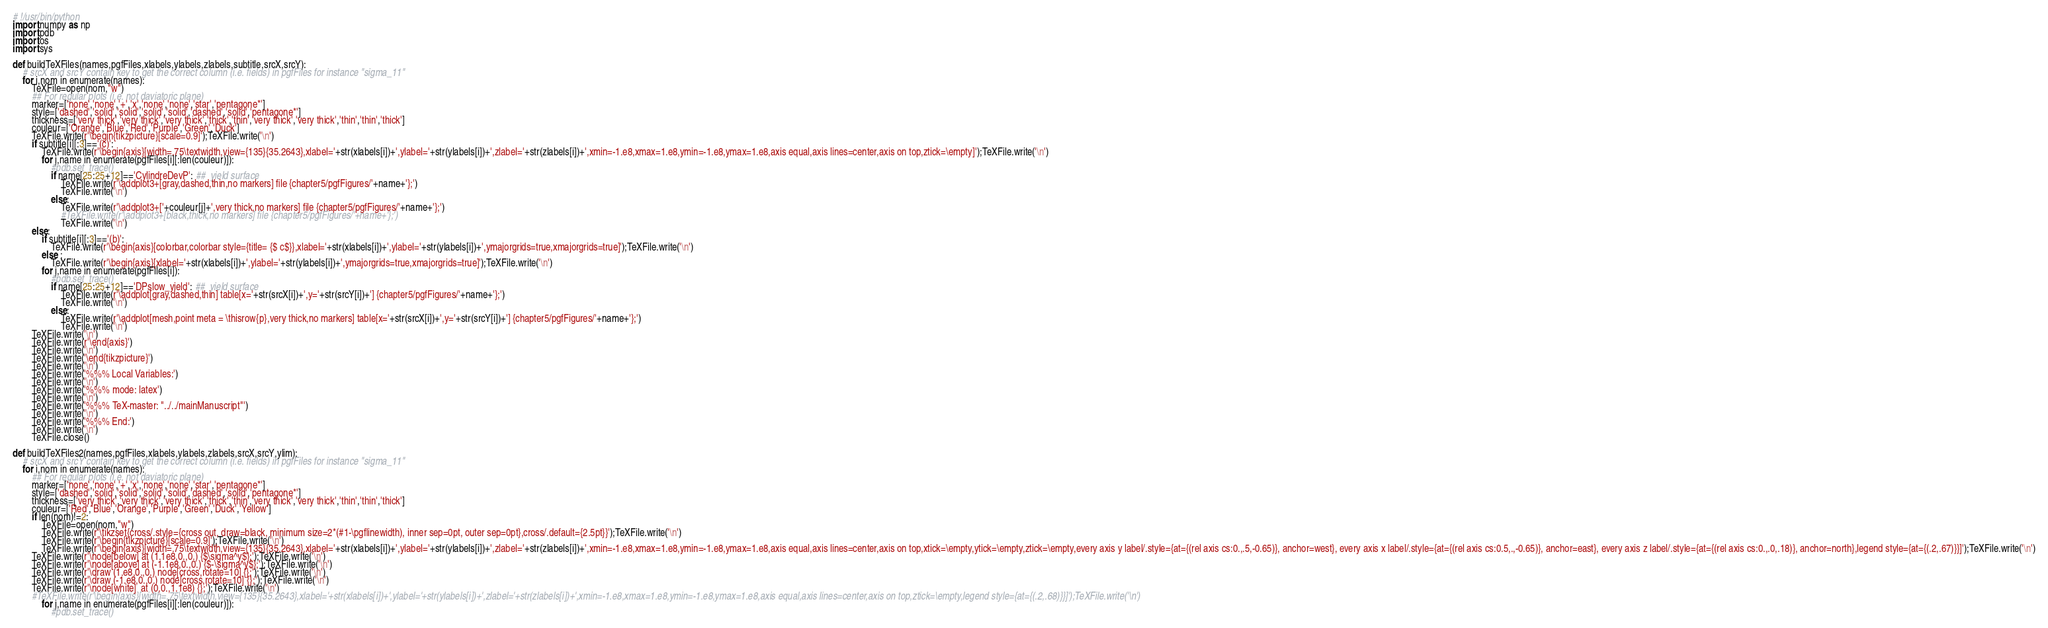<code> <loc_0><loc_0><loc_500><loc_500><_Python_># !/usr/bin/python
import numpy as np
import pdb
import os
import sys

def buildTeXFiles(names,pgfFiles,xlabels,ylabels,zlabels,subtitle,srcX,srcY):
    # srcX and srcY contain key to get the correct column (i.e. fields) in pgfFiles for instance "sigma_11"
    for i,nom in enumerate(names):
        TeXFile=open(nom,"w")
        ## For regular plots (i.e. not daviatoric plane)
        marker=['none','none','+','x','none','none','star','pentagone*']
        style=['dashed','solid','solid','solid','solid','dashed','solid','pentagone*']
        thickness=['very thick','very thick','very thick','thick','thin','very thick','very thick','thin','thin','thick']
        couleur=['Orange','Blue','Red','Purple','Green','Duck']
        TeXFile.write(r'\begin{tikzpicture}[scale=0.9]');TeXFile.write('\n')
        if subtitle[i][:3]=='(c)':
            TeXFile.write(r'\begin{axis}[width=.75\textwidth,view={135}{35.2643},xlabel='+str(xlabels[i])+',ylabel='+str(ylabels[i])+',zlabel='+str(zlabels[i])+',xmin=-1.e8,xmax=1.e8,ymin=-1.e8,ymax=1.e8,axis equal,axis lines=center,axis on top,ztick=\empty]');TeXFile.write('\n')
            for j,name in enumerate(pgfFiles[i][:len(couleur)]):
                #pdb.set_trace()
                if name[25:25+12]=='CylindreDevP': ##  yield surface
                    TeXFile.write(r'\addplot3+[gray,dashed,thin,no markers] file {chapter5/pgfFigures/'+name+'};')
                    TeXFile.write('\n')
                else:
                    TeXFile.write(r'\addplot3+['+couleur[j]+',very thick,no markers] file {chapter5/pgfFigures/'+name+'};')
                    #TeXFile.write(r'\addplot3+[black,thick,no markers] file {chapter5/pgfFigures/'+name+'};')
                    TeXFile.write('\n')
        else:
            if subtitle[i][:3]=='(b)':
                TeXFile.write(r'\begin{axis}[colorbar,colorbar style={title= {$ c$}},xlabel='+str(xlabels[i])+',ylabel='+str(ylabels[i])+',ymajorgrids=true,xmajorgrids=true]');TeXFile.write('\n')
            else :
                TeXFile.write(r'\begin{axis}[xlabel='+str(xlabels[i])+',ylabel='+str(ylabels[i])+',ymajorgrids=true,xmajorgrids=true]');TeXFile.write('\n')
            for j,name in enumerate(pgfFiles[i]):
                #pdb.set_trace()
                if name[25:25+12]=='DPslow_yield': ##  yield surface
                    TeXFile.write(r'\addplot[gray,dashed,thin] table[x='+str(srcX[i])+',y='+str(srcY[i])+'] {chapter5/pgfFigures/'+name+'};')
                    TeXFile.write('\n')
                else:
                    TeXFile.write(r'\addplot[mesh,point meta = \thisrow{p},very thick,no markers] table[x='+str(srcX[i])+',y='+str(srcY[i])+'] {chapter5/pgfFigures/'+name+'};')
                    TeXFile.write('\n')
        TeXFile.write('\n')    
        TeXFile.write(r'\end{axis}')
        TeXFile.write('\n')
        TeXFile.write('\end{tikzpicture}')
        TeXFile.write('\n')
        TeXFile.write('%%% Local Variables:')
        TeXFile.write('\n')
        TeXFile.write('%%% mode: latex')
        TeXFile.write('\n')
        TeXFile.write('%%% TeX-master: "../../mainManuscript"')
        TeXFile.write('\n')
        TeXFile.write('%%% End:')
        TeXFile.write('\n')
        TeXFile.close()

def buildTeXFiles2(names,pgfFiles,xlabels,ylabels,zlabels,srcX,srcY,ylim):
    # srcX and srcY contain key to get the correct column (i.e. fields) in pgfFiles for instance "sigma_11"
    for i,nom in enumerate(names):
        ## For regular plots (i.e. not daviatoric plane)
        marker=['none','none','+','x','none','none','star','pentagone*']
        style=['dashed','solid','solid','solid','solid','dashed','solid','pentagone*']
        thickness=['very thick','very thick','very thick','thick','thin','very thick','very thick','thin','thin','thick']
        couleur=['Red','Blue','Orange','Purple','Green','Duck','Yellow']
        if len(nom)!=2:
            TeXFile=open(nom,"w")
            TeXFile.write(r'\tikzset{cross/.style={cross out, draw=black, minimum size=2*(#1-\pgflinewidth), inner sep=0pt, outer sep=0pt},cross/.default={2.5pt}}');TeXFile.write('\n')
            TeXFile.write(r'\begin{tikzpicture}[scale=0.9]');TeXFile.write('\n')
            TeXFile.write(r'\begin{axis}[width=.75\textwidth,view={135}{35.2643},xlabel='+str(xlabels[i])+',ylabel='+str(ylabels[i])+',zlabel='+str(zlabels[i])+',xmin=-1.e8,xmax=1.e8,ymin=-1.e8,ymax=1.e8,axis equal,axis lines=center,axis on top,xtick=\empty,ytick=\empty,ztick=\empty,every axis y label/.style={at={(rel axis cs:0.,.5,-0.65)}, anchor=west}, every axis x label/.style={at={(rel axis cs:0.5,.,-0.65)}, anchor=east}, every axis z label/.style={at={(rel axis cs:0.,.0,.18)}, anchor=north},legend style={at={(.2,.67)}}]');TeXFile.write('\n')
	    TeXFile.write(r'\node[below] at (1.1e8,0.,0.) {$\sigma^y$};');TeXFile.write('\n')
	    TeXFile.write(r'\node[above] at (-1.1e8,0.,0.) {$-\sigma^y$};');TeXFile.write('\n')
	    TeXFile.write(r'\draw (1.e8,0.,0.) node[cross,rotate=10] {};');TeXFile.write('\n')
	    TeXFile.write(r'\draw (-1.e8,0.,0.) node[cross,rotate=10] {};');TeXFile.write('\n')
	    TeXFile.write(r'\node[white]  at (0,0.,1.1e8) {};');TeXFile.write('\n')
	    #TeXFile.write(r'\begin{axis}[width=.75\textwidth,view={135}{35.2643},xlabel='+str(xlabels[i])+',ylabel='+str(ylabels[i])+',zlabel='+str(zlabels[i])+',xmin=-1.e8,xmax=1.e8,ymin=-1.e8,ymax=1.e8,axis equal,axis lines=center,axis on top,ztick=\empty,legend style={at={(.2,.68)}}]');TeXFile.write('\n')
            for j,name in enumerate(pgfFiles[i][:len(couleur)]):
                #pdb.set_trace()</code> 